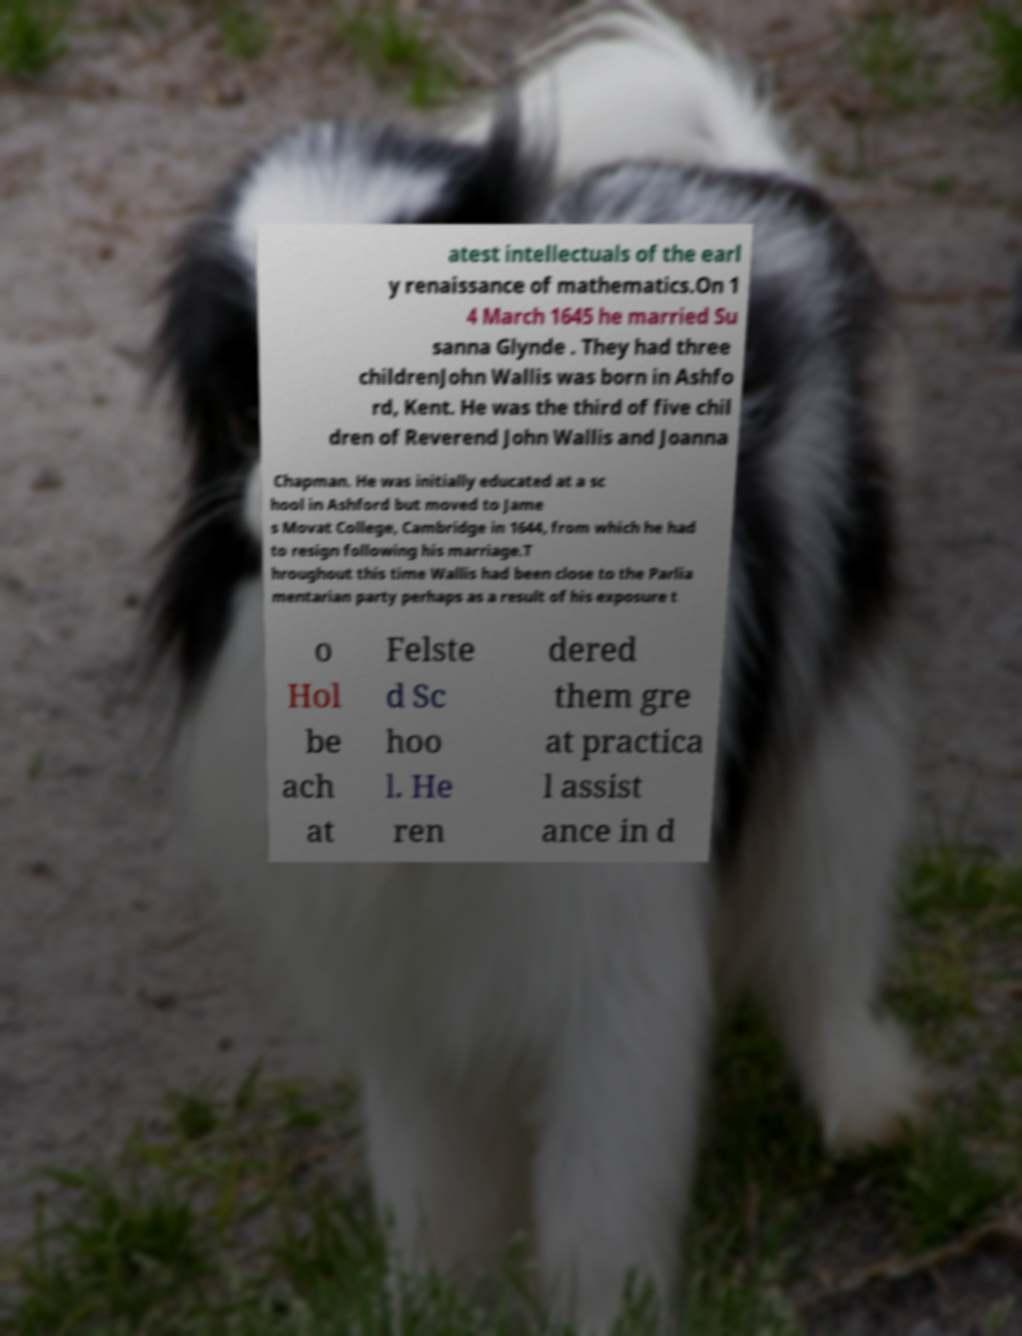Could you extract and type out the text from this image? atest intellectuals of the earl y renaissance of mathematics.On 1 4 March 1645 he married Su sanna Glynde . They had three childrenJohn Wallis was born in Ashfo rd, Kent. He was the third of five chil dren of Reverend John Wallis and Joanna Chapman. He was initially educated at a sc hool in Ashford but moved to Jame s Movat College, Cambridge in 1644, from which he had to resign following his marriage.T hroughout this time Wallis had been close to the Parlia mentarian party perhaps as a result of his exposure t o Hol be ach at Felste d Sc hoo l. He ren dered them gre at practica l assist ance in d 